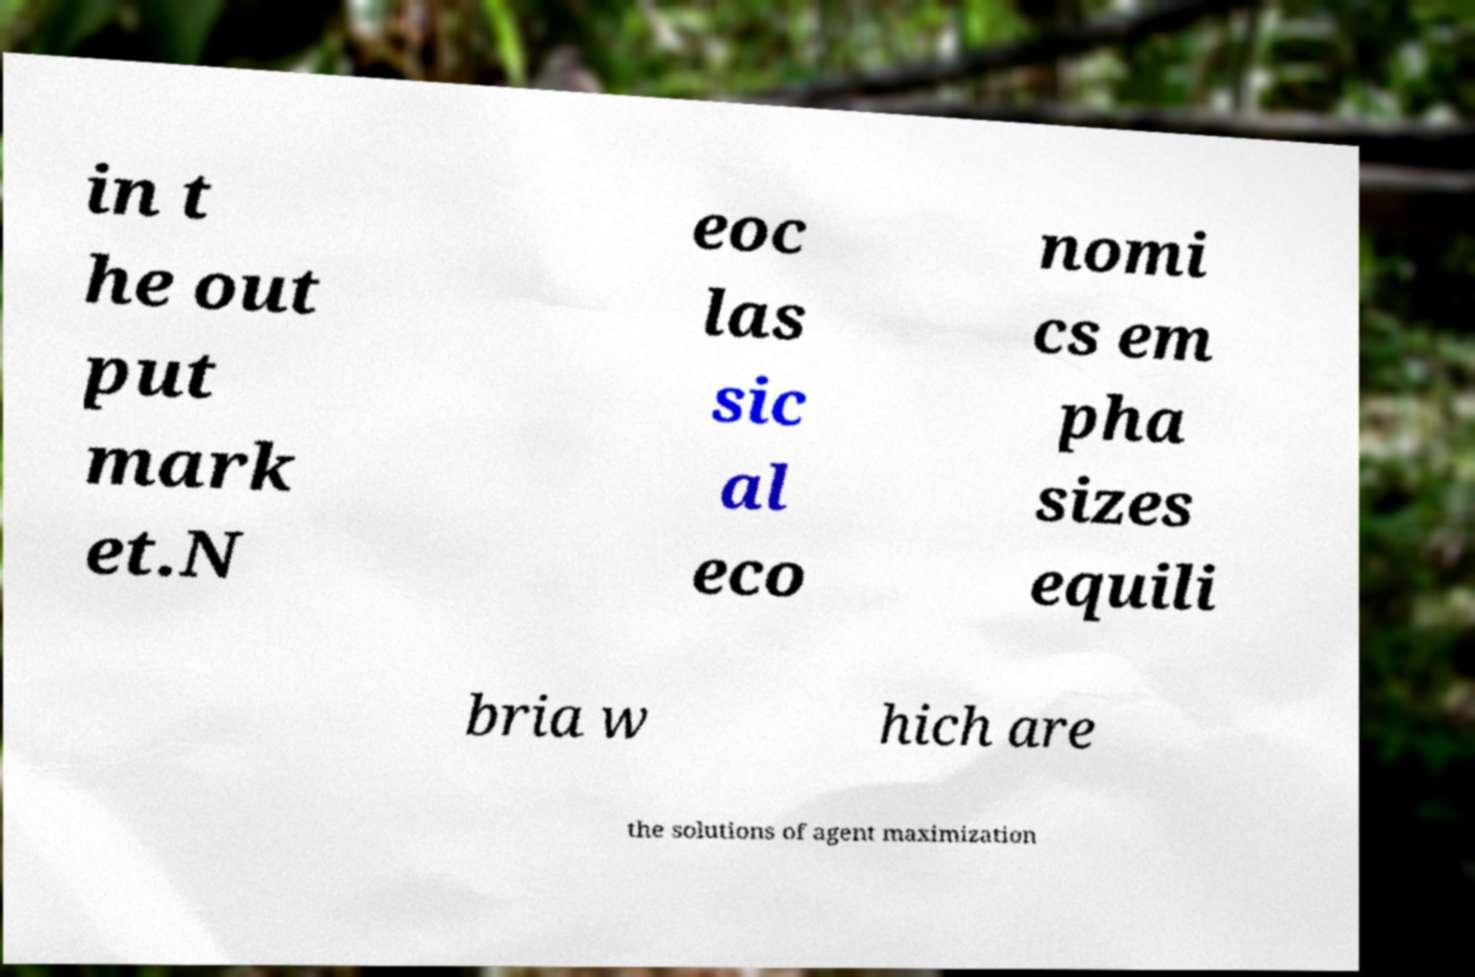Could you extract and type out the text from this image? in t he out put mark et.N eoc las sic al eco nomi cs em pha sizes equili bria w hich are the solutions of agent maximization 